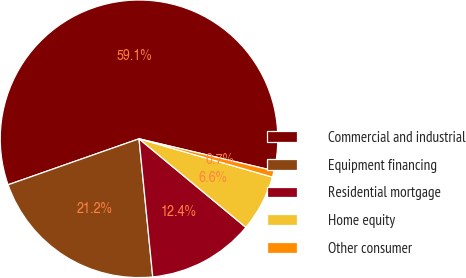<chart> <loc_0><loc_0><loc_500><loc_500><pie_chart><fcel>Commercial and industrial<fcel>Equipment financing<fcel>Residential mortgage<fcel>Home equity<fcel>Other consumer<nl><fcel>59.08%<fcel>21.2%<fcel>12.41%<fcel>6.57%<fcel>0.74%<nl></chart> 